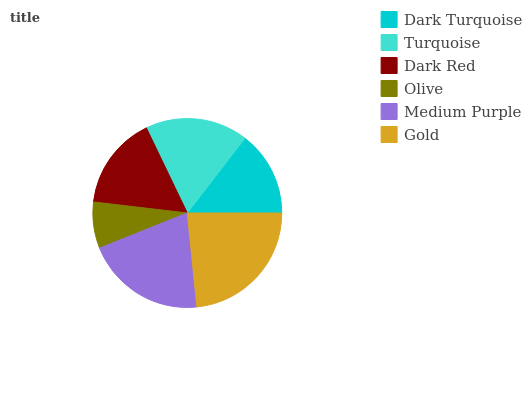Is Olive the minimum?
Answer yes or no. Yes. Is Gold the maximum?
Answer yes or no. Yes. Is Turquoise the minimum?
Answer yes or no. No. Is Turquoise the maximum?
Answer yes or no. No. Is Turquoise greater than Dark Turquoise?
Answer yes or no. Yes. Is Dark Turquoise less than Turquoise?
Answer yes or no. Yes. Is Dark Turquoise greater than Turquoise?
Answer yes or no. No. Is Turquoise less than Dark Turquoise?
Answer yes or no. No. Is Turquoise the high median?
Answer yes or no. Yes. Is Dark Red the low median?
Answer yes or no. Yes. Is Medium Purple the high median?
Answer yes or no. No. Is Turquoise the low median?
Answer yes or no. No. 